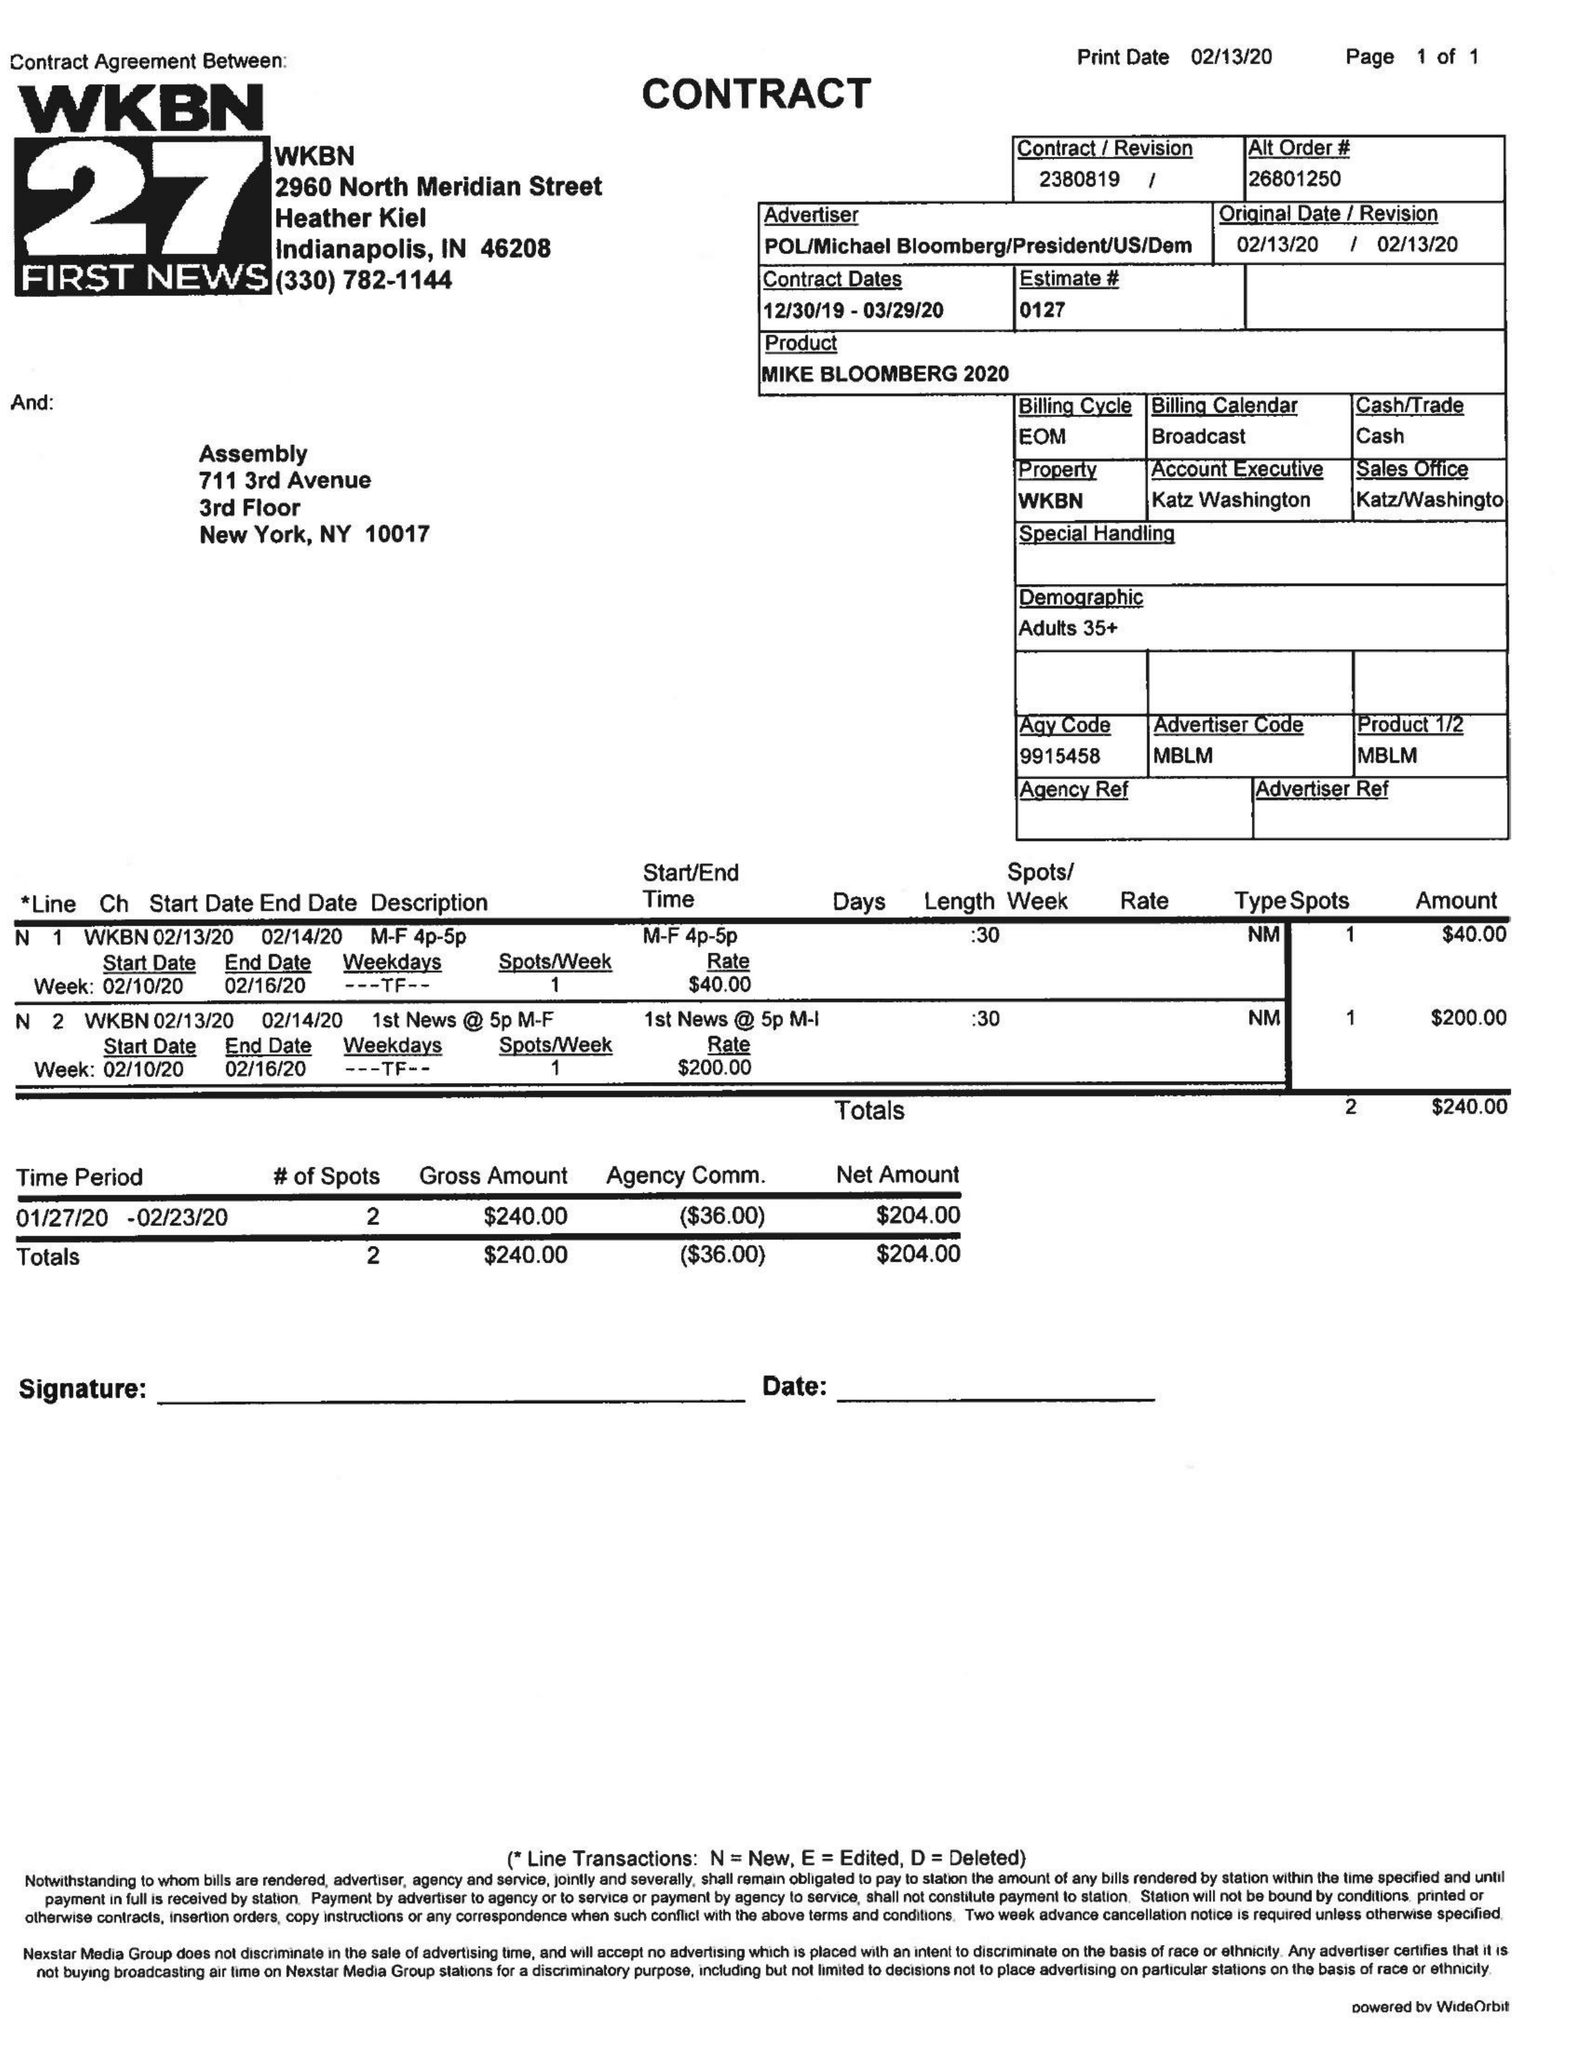What is the value for the flight_to?
Answer the question using a single word or phrase. 03/29/20 